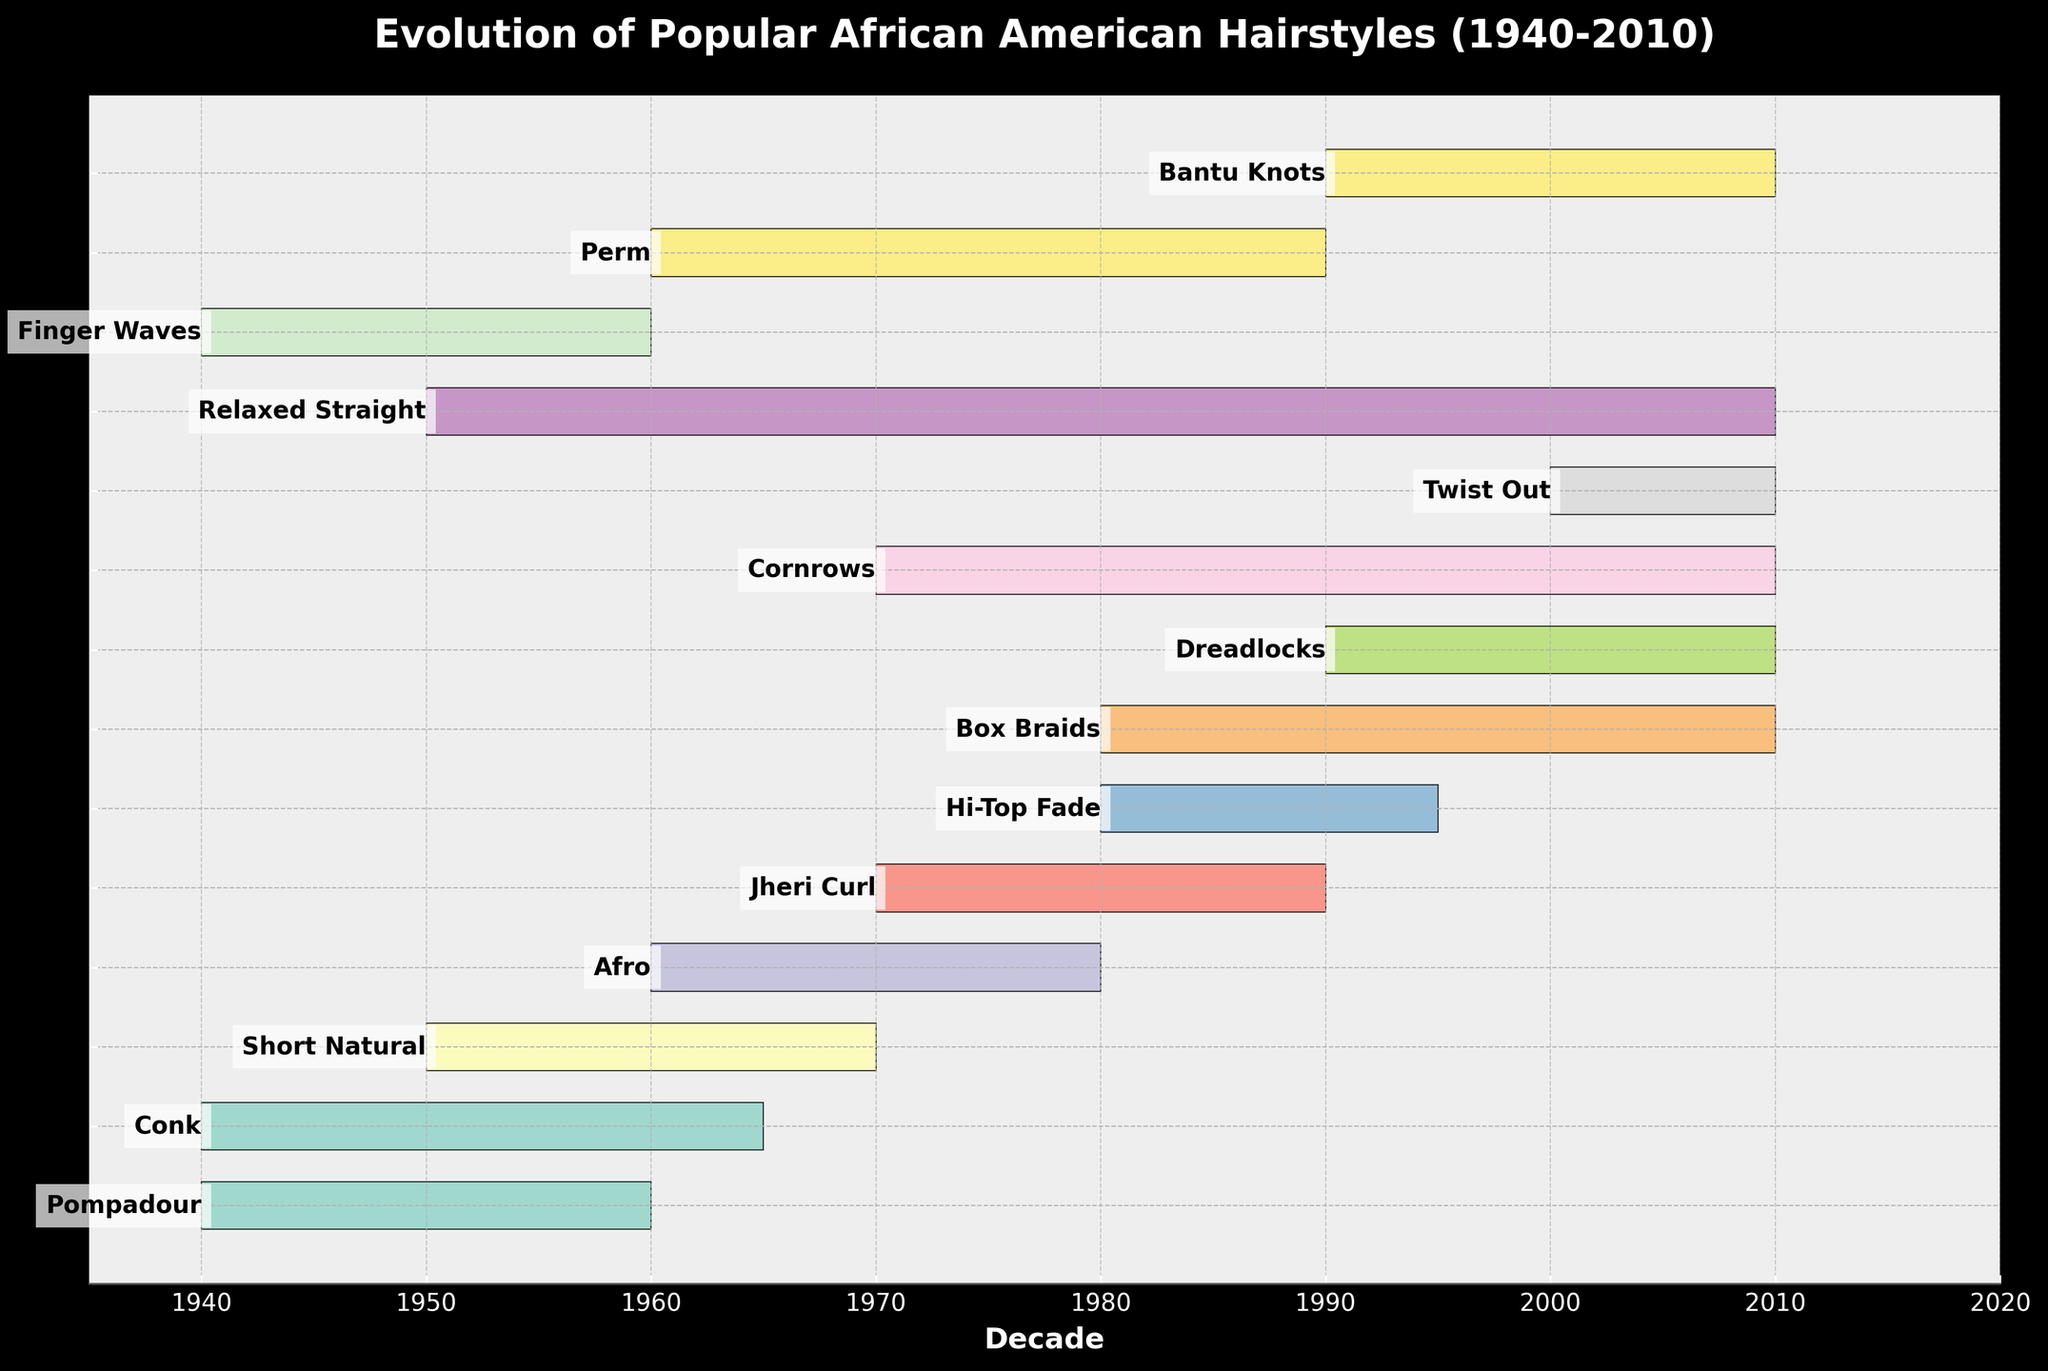What is the title of the chart? The title of the chart is written at the top and provides a summary of the chart's contents. The title reads "Evolution of Popular African American Hairstyles (1940-2010)."
Answer: Evolution of Popular African American Hairstyles (1940-2010) How many distinct hairstyles are shown in the chart? Count each labeled bar on the y-axis. The chart displays 14 different hairstyles.
Answer: 14 Which hairstyle had the shortest duration of popularity? Compare the length of the bars representing each hairstyle. "Twist Out" lasted from 2000 to 2010, for a total of 10 years.
Answer: Twist Out Between the hairstyles "Afro" and "Hi-Top Fade", which had a longer period of popularity? "Afro" spanned from 1960 to 1980 (20 years), while "Hi-Top Fade" spanned from 1980 to 1995 (15 years). By comparing the two, "Afro" had a longer period of popularity.
Answer: Afro During which decades did both "Conk" and "Short Natural" overlap in popularity? "Conk" was popular from 1940 to 1965 and "Short Natural" from 1950 to 1970. Their overlapping period is from 1950 to 1965.
Answer: 1950s to mid-1960s Which hairstyle had the longest period of popularity, and how many years was it popular? Identify the hairstyle with the longest bar. "Relaxed Straight" spans from 1950 to 2010, which is 60 years.
Answer: Relaxed Straight, 60 years How many hairstyles were popular during the 1990s? Examine the bars that include the decade of 1990s. "Hi-Top Fade", "Box Braids", "Dreadlocks", "Cornrows", "Jheri Curl", "Perm", "Bantu Knots" were popular during the 1990s. Count them.
Answer: 7 Which hairstyles were popular during both the 1980s and 1990s? Identify the hairstyles whose bars cover both the 1980s and 1990s. These are "Hi-Top Fade", "Box Braids", "Jheri Curl", and "Perm".
Answer: Hi-Top Fade, Box Braids, Jheri Curl, Perm Were there more hairstyles introduced in the 1940s or the 2000s? Count the hairstyles introduced in each decade: "1940s" (Pompadour, Conk, Finger Waves); "2000s" (Twist Out). There were more introductions in the 1940s.
Answer: 1940s How long did the "Jheri Curl" remain popular? Look at the timeframe of the "Jheri Curl" bar. It spans from 1970 to 1990, lasting 20 years.
Answer: 20 years 